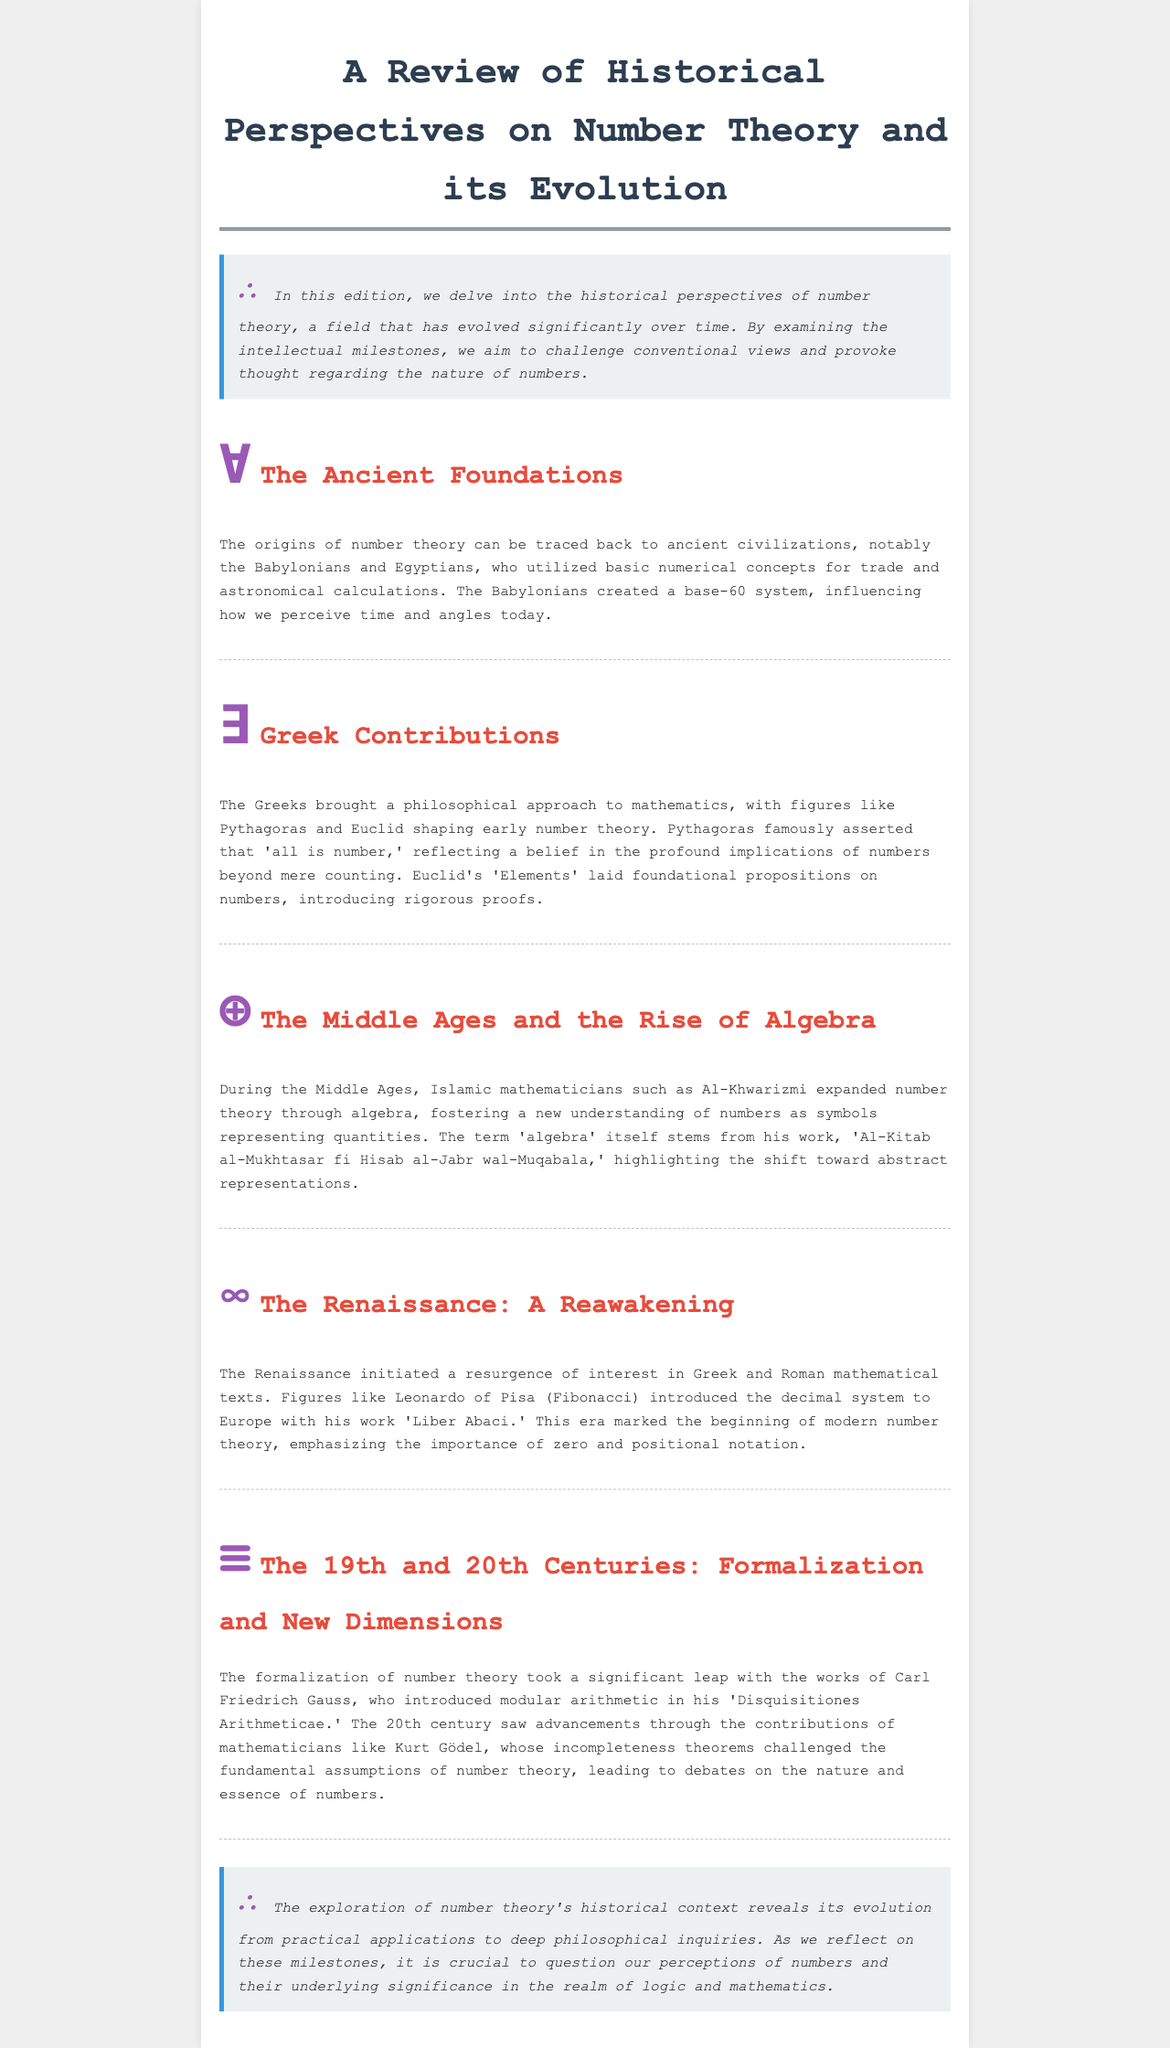What civilization is credited with creating a base-60 system? The document states that the Babylonians utilized a base-60 system, influencing modern perceptions of time and angles.
Answer: Babylonians Who introduced the term 'algebra'? The document mentions that the term 'algebra' stems from the work of Al-Khwarizmi, highlighting a shift toward abstract representations of numbers.
Answer: Al-Khwarizmi What is the title of Fibonacci's work that introduced the decimal system to Europe? The document references the work 'Liber Abaci' by Fibonacci that played a significant role in introducing the decimal system to Europe.
Answer: Liber Abaci Which mathematician introduced modular arithmetic? The document states that Carl Friedrich Gauss introduced modular arithmetic in his work 'Disquisitiones Arithmeticae.'
Answer: Carl Friedrich Gauss What philosophical belief did Pythagoras famously assert? The document quotes Pythagoras's belief that 'all is number,' which reflects his philosophical view on the significance of numbers.
Answer: All is number In which century did the Renaissance occur? The Renaissance era is generally accepted to be around the 14th to 17th centuries, indicating a period of reawakening in interest in mathematical texts.
Answer: 14th to 17th centuries What significant mathematical contribution did Kurt Gödel make? The document states that Kurt Gödel's contributions included the incompleteness theorems, which challenged fundamental assumptions of number theory.
Answer: Incompleteness theorems What were the 'Elements' introduced by Euclid? The document indicates that Euclid's 'Elements' laid foundational propositions on numbers, introducing rigorous proofs in the field of mathematics.
Answer: Elements What is the primary theme explored in this newsletter? The document discusses the evolution of number theory and its transformation from practical applications to philosophical inquiries regarding the nature of numbers.
Answer: Evolution of number theory 